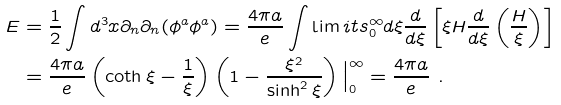Convert formula to latex. <formula><loc_0><loc_0><loc_500><loc_500>E & = \frac { 1 } { 2 } \int d ^ { 3 } x \partial _ { n } \partial _ { n } ( \phi ^ { a } \phi ^ { a } ) = \frac { 4 \pi a } { e } \int \lim i t s _ { 0 } ^ { \infty } d \xi \frac { d } { d \xi } \left [ \xi H \frac { d } { d \xi } \left ( \frac { H } { \xi } \right ) \right ] \\ & = \frac { 4 \pi a } { e } \left ( \coth \xi - \frac { 1 } { \xi } \right ) \left ( 1 - \frac { \xi ^ { 2 } } { \sinh ^ { 2 } \xi } \right ) { \Big | \Big . } _ { 0 } ^ { \infty } = \frac { 4 \pi a } { e } \ .</formula> 